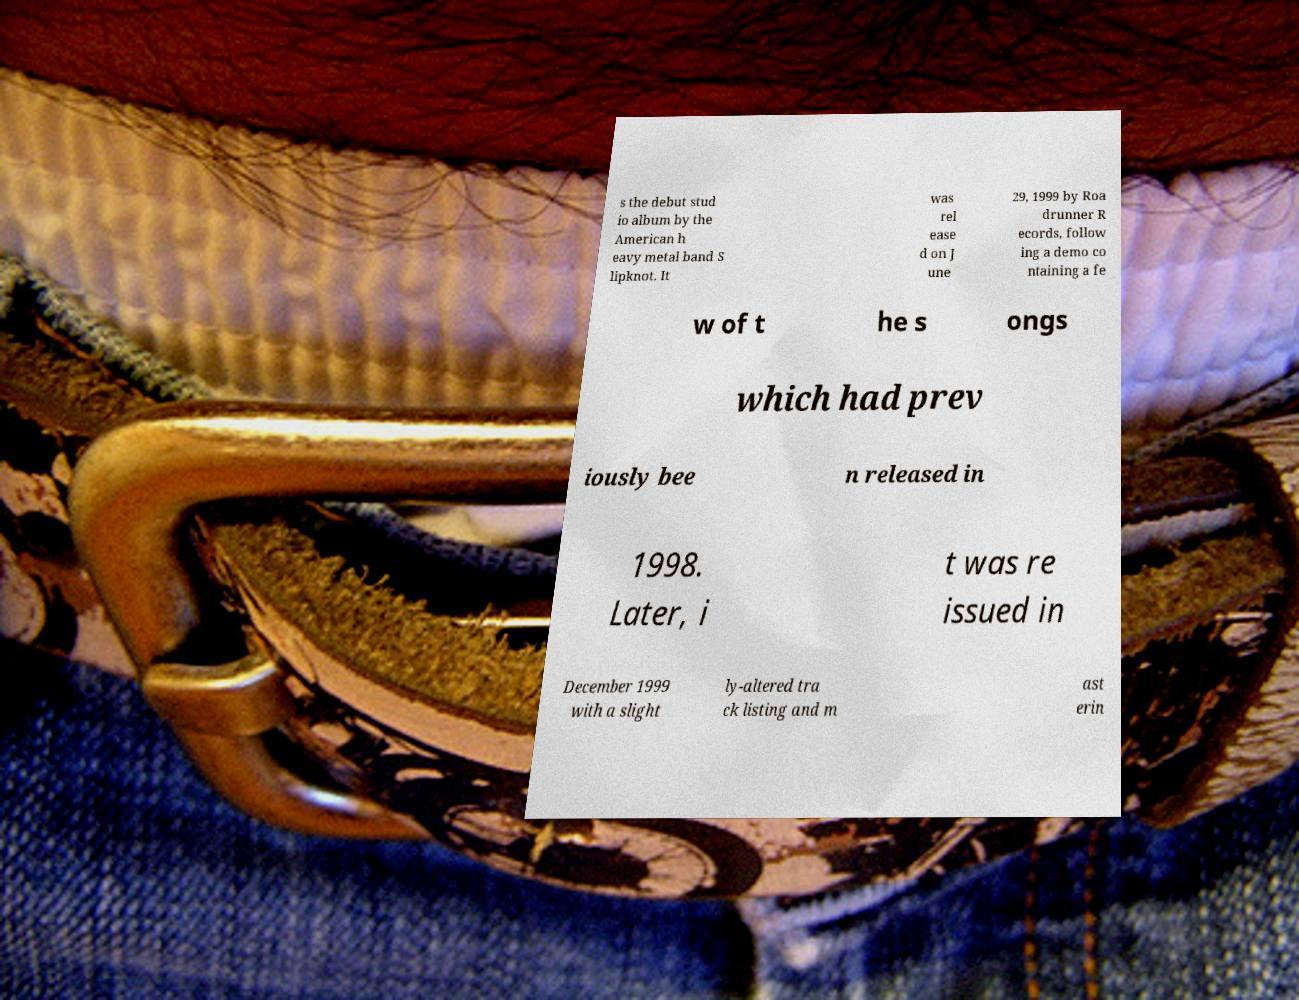Could you extract and type out the text from this image? s the debut stud io album by the American h eavy metal band S lipknot. It was rel ease d on J une 29, 1999 by Roa drunner R ecords, follow ing a demo co ntaining a fe w of t he s ongs which had prev iously bee n released in 1998. Later, i t was re issued in December 1999 with a slight ly-altered tra ck listing and m ast erin 